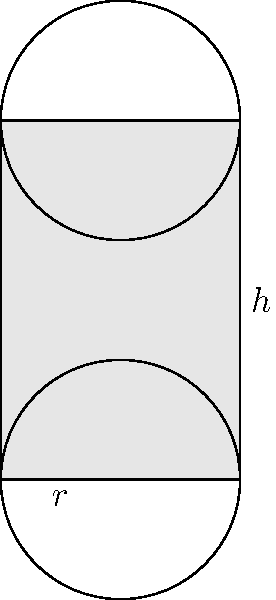As a crop farmer, you need to optimize the packing of cylindrical vegetable crates for efficient transportation. Given cylindrical crates with radius $r$ and height $h$, what is the maximum number of crates that can be packed into a rectangular truck bed with dimensions $L \times W \times H$? Assume the crates are placed upright and can be arranged in a grid-like pattern. To find the maximum number of cylindrical crates that can be packed into the rectangular truck bed, we need to follow these steps:

1. Determine the number of crates that can fit along the length (L) of the truck bed:
   $n_L = \left\lfloor\frac{L}{2r}\right\rfloor$

2. Determine the number of crates that can fit along the width (W) of the truck bed:
   $n_W = \left\lfloor\frac{W}{2r}\right\rfloor$

3. Determine the number of crates that can be stacked vertically (H):
   $n_H = \left\lfloor\frac{H}{h}\right\rfloor$

4. Calculate the total number of crates by multiplying the results from steps 1, 2, and 3:
   $N_{total} = n_L \times n_W \times n_H$

5. Substitute the given dimensions:
   $N_{total} = \left\lfloor\frac{L}{2r}\right\rfloor \times \left\lfloor\frac{W}{2r}\right\rfloor \times \left\lfloor\frac{H}{h}\right\rfloor$

This formula gives the maximum number of cylindrical crates that can be packed into the rectangular truck bed, assuming an optimal grid-like arrangement.
Answer: $N_{total} = \left\lfloor\frac{L}{2r}\right\rfloor \times \left\lfloor\frac{W}{2r}\right\rfloor \times \left\lfloor\frac{H}{h}\right\rfloor$ 